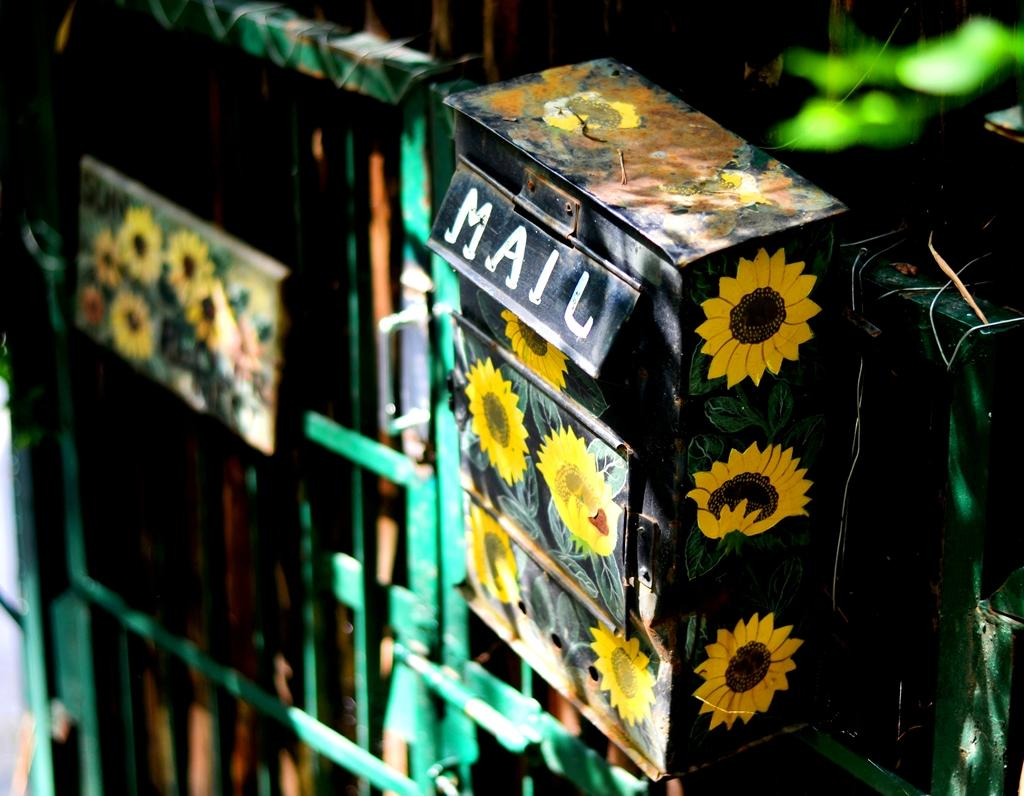What object is the main focus of the image? There is a post box in the image. What else can be seen in the image besides the post box? There is a board hanging on a gate in the image. What type of vegetation is visible in the image? Leaves are visible at the top right side of the image. What arithmetic problem is being solved on the board hanging on the gate in the image? There is no arithmetic problem visible on the board in the image. What is the source of fear in the image? There is no indication of fear in the image, as it features a post box, a board hanging on a gate, and leaves. 